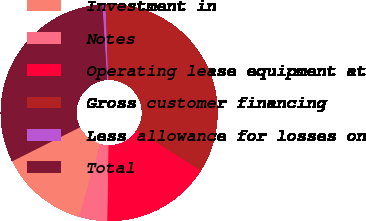Convert chart. <chart><loc_0><loc_0><loc_500><loc_500><pie_chart><fcel>Investment in<fcel>Notes<fcel>Operating lease equipment at<fcel>Gross customer financing<fcel>Less allowance for losses on<fcel>Total<nl><fcel>13.14%<fcel>4.21%<fcel>16.28%<fcel>34.54%<fcel>0.43%<fcel>31.4%<nl></chart> 